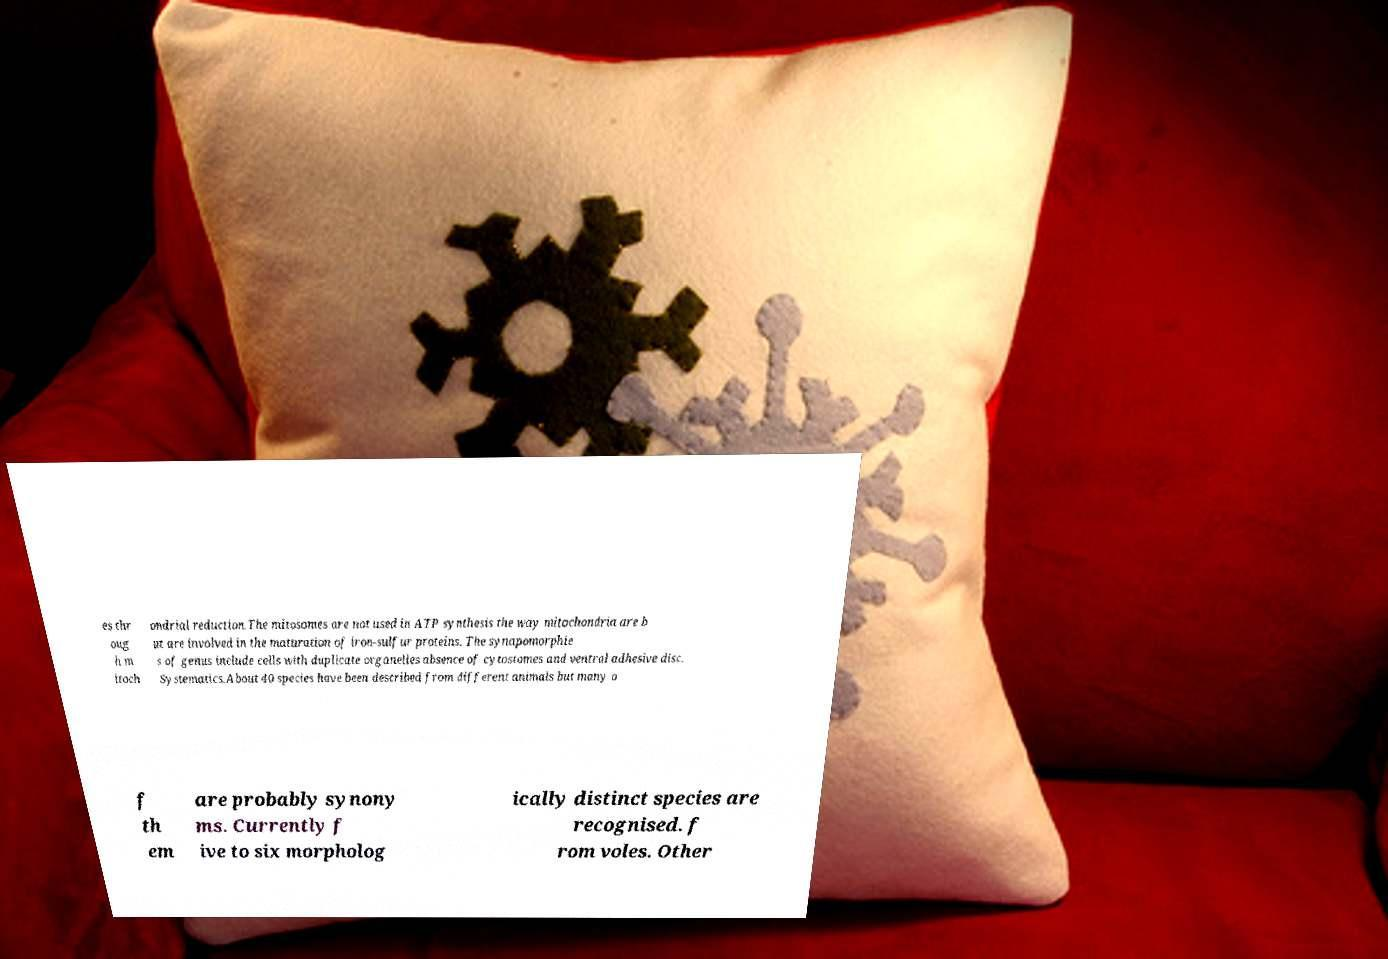I need the written content from this picture converted into text. Can you do that? es thr oug h m itoch ondrial reduction.The mitosomes are not used in ATP synthesis the way mitochondria are b ut are involved in the maturation of iron-sulfur proteins. The synapomorphie s of genus include cells with duplicate organelles absence of cytostomes and ventral adhesive disc. Systematics.About 40 species have been described from different animals but many o f th em are probably synony ms. Currently f ive to six morpholog ically distinct species are recognised. f rom voles. Other 